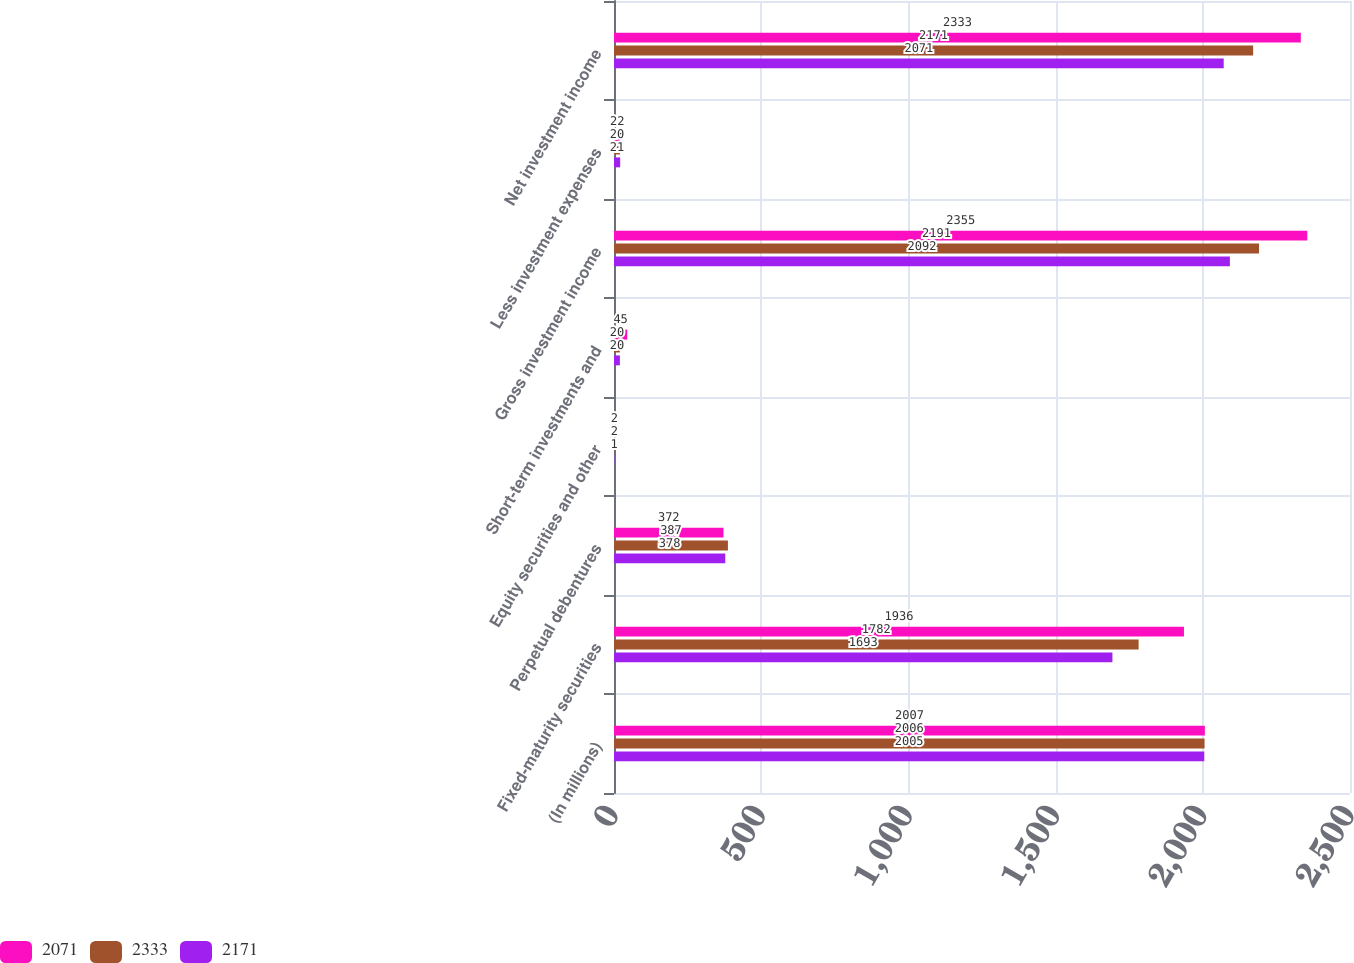Convert chart. <chart><loc_0><loc_0><loc_500><loc_500><stacked_bar_chart><ecel><fcel>(In millions)<fcel>Fixed-maturity securities<fcel>Perpetual debentures<fcel>Equity securities and other<fcel>Short-term investments and<fcel>Gross investment income<fcel>Less investment expenses<fcel>Net investment income<nl><fcel>2071<fcel>2007<fcel>1936<fcel>372<fcel>2<fcel>45<fcel>2355<fcel>22<fcel>2333<nl><fcel>2333<fcel>2006<fcel>1782<fcel>387<fcel>2<fcel>20<fcel>2191<fcel>20<fcel>2171<nl><fcel>2171<fcel>2005<fcel>1693<fcel>378<fcel>1<fcel>20<fcel>2092<fcel>21<fcel>2071<nl></chart> 